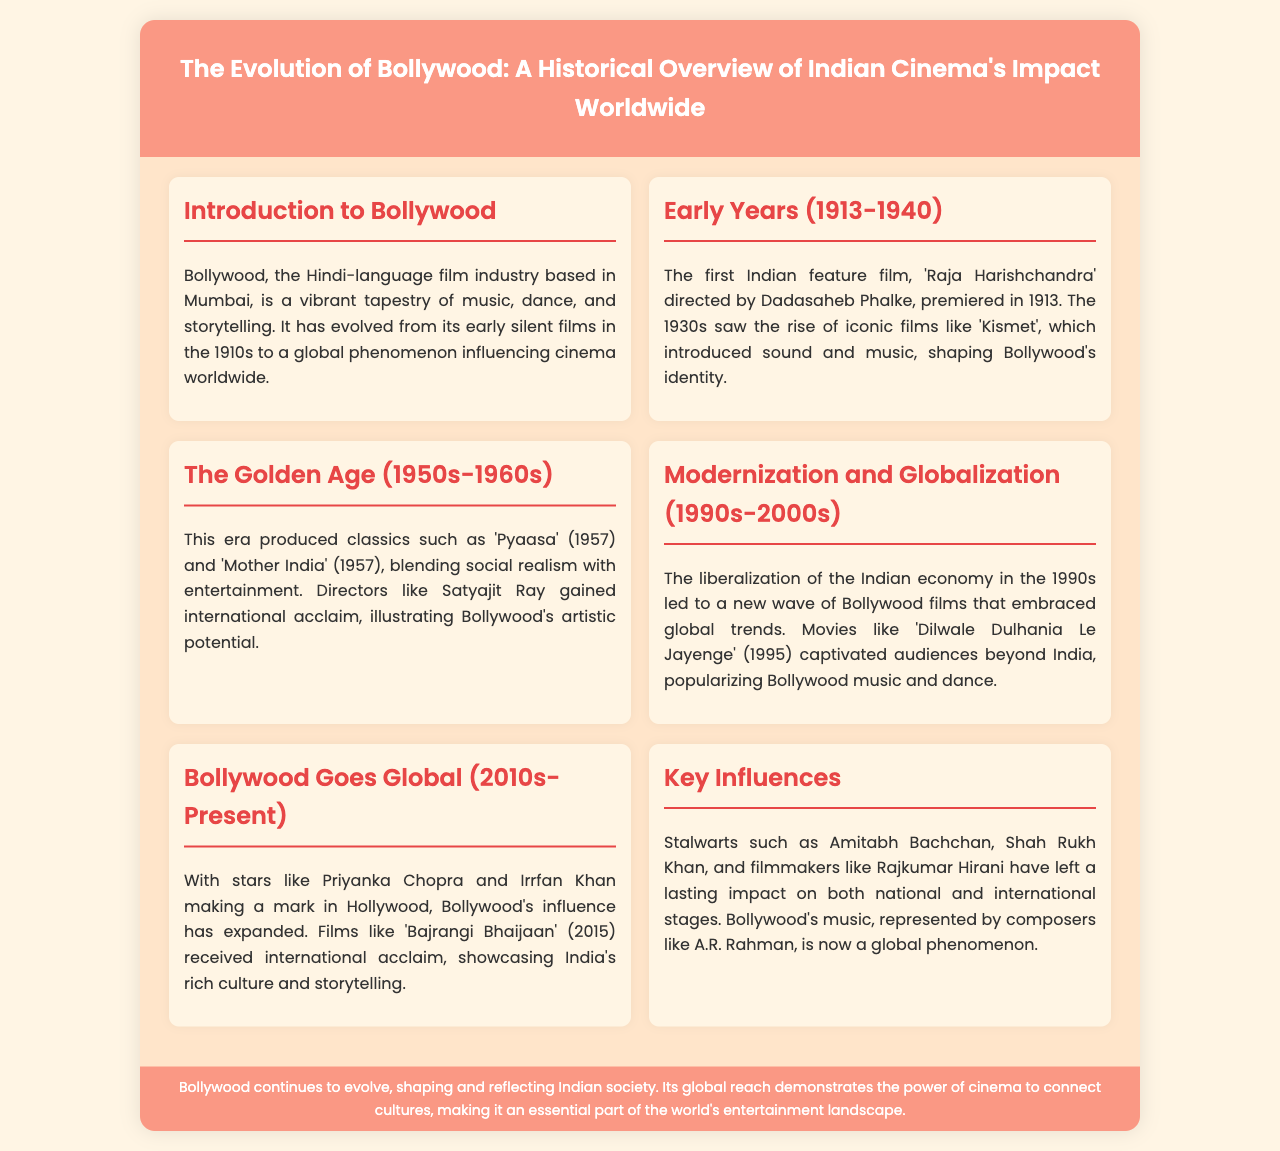What was the first Indian feature film? The document states that 'Raja Harishchandra' directed by Dadasaheb Phalke premiered in 1913 as the first Indian feature film.
Answer: 'Raja Harishchandra' Which decade marked the Golden Age of Bollywood? According to the document, the Golden Age of Bollywood is identified as the 1950s-1960s.
Answer: 1950s-1960s Who is a notable director mentioned in the Golden Age? The document highlights Satyajit Ray as a director who gained international acclaim during the Golden Age.
Answer: Satyajit Ray What major economic change influenced Bollywood in the 1990s? The document mentions the liberalization of the Indian economy as a significant change affecting Bollywood in the 1990s.
Answer: Liberalization of the Indian economy Which film from the document was released in 1995? The film 'Dilwale Dulhania Le Jayenge' is specifically mentioned as a movie from 1995 that captivated audiences.
Answer: 'Dilwale Dulhania Le Jayenge' What global influence has Priyanka Chopra had? The document indicates that Priyanka Chopra made a mark in Hollywood, showcasing Bollywood's expansion.
Answer: Hollywood What is the name of a prominent composer associated with Bollywood? A.R. Rahman is highlighted in the document as a composer whose music has a global presence.
Answer: A.R. Rahman What does the brochure express about Bollywood's impact on society? The document states that Bollywood shapes and reflects Indian society, illustrating its cultural significance.
Answer: Shapes and reflects Indian society 